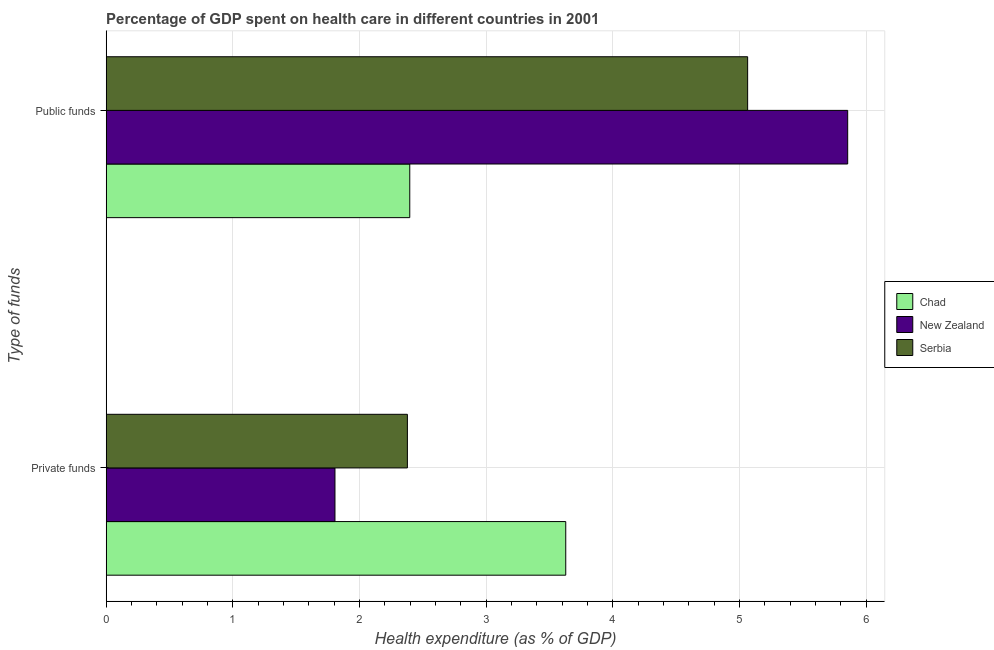How many groups of bars are there?
Provide a short and direct response. 2. Are the number of bars per tick equal to the number of legend labels?
Make the answer very short. Yes. What is the label of the 1st group of bars from the top?
Your answer should be very brief. Public funds. What is the amount of private funds spent in healthcare in New Zealand?
Offer a very short reply. 1.81. Across all countries, what is the maximum amount of public funds spent in healthcare?
Make the answer very short. 5.85. Across all countries, what is the minimum amount of private funds spent in healthcare?
Give a very brief answer. 1.81. In which country was the amount of public funds spent in healthcare maximum?
Offer a very short reply. New Zealand. In which country was the amount of public funds spent in healthcare minimum?
Give a very brief answer. Chad. What is the total amount of public funds spent in healthcare in the graph?
Provide a succinct answer. 13.31. What is the difference between the amount of public funds spent in healthcare in New Zealand and that in Serbia?
Provide a short and direct response. 0.79. What is the difference between the amount of private funds spent in healthcare in New Zealand and the amount of public funds spent in healthcare in Serbia?
Your answer should be very brief. -3.26. What is the average amount of public funds spent in healthcare per country?
Offer a terse response. 4.44. What is the difference between the amount of public funds spent in healthcare and amount of private funds spent in healthcare in Serbia?
Ensure brevity in your answer.  2.69. What is the ratio of the amount of public funds spent in healthcare in New Zealand to that in Chad?
Ensure brevity in your answer.  2.44. What does the 1st bar from the top in Private funds represents?
Provide a short and direct response. Serbia. What does the 3rd bar from the bottom in Public funds represents?
Give a very brief answer. Serbia. How many bars are there?
Your answer should be very brief. 6. Are all the bars in the graph horizontal?
Make the answer very short. Yes. How many countries are there in the graph?
Offer a terse response. 3. What is the difference between two consecutive major ticks on the X-axis?
Give a very brief answer. 1. How many legend labels are there?
Ensure brevity in your answer.  3. How are the legend labels stacked?
Provide a succinct answer. Vertical. What is the title of the graph?
Offer a very short reply. Percentage of GDP spent on health care in different countries in 2001. Does "Middle East & North Africa (all income levels)" appear as one of the legend labels in the graph?
Keep it short and to the point. No. What is the label or title of the X-axis?
Offer a terse response. Health expenditure (as % of GDP). What is the label or title of the Y-axis?
Keep it short and to the point. Type of funds. What is the Health expenditure (as % of GDP) of Chad in Private funds?
Your answer should be very brief. 3.63. What is the Health expenditure (as % of GDP) of New Zealand in Private funds?
Offer a terse response. 1.81. What is the Health expenditure (as % of GDP) of Serbia in Private funds?
Make the answer very short. 2.38. What is the Health expenditure (as % of GDP) in Chad in Public funds?
Your answer should be compact. 2.4. What is the Health expenditure (as % of GDP) of New Zealand in Public funds?
Ensure brevity in your answer.  5.85. What is the Health expenditure (as % of GDP) in Serbia in Public funds?
Keep it short and to the point. 5.06. Across all Type of funds, what is the maximum Health expenditure (as % of GDP) of Chad?
Provide a succinct answer. 3.63. Across all Type of funds, what is the maximum Health expenditure (as % of GDP) of New Zealand?
Provide a short and direct response. 5.85. Across all Type of funds, what is the maximum Health expenditure (as % of GDP) of Serbia?
Provide a succinct answer. 5.06. Across all Type of funds, what is the minimum Health expenditure (as % of GDP) in Chad?
Make the answer very short. 2.4. Across all Type of funds, what is the minimum Health expenditure (as % of GDP) of New Zealand?
Your answer should be very brief. 1.81. Across all Type of funds, what is the minimum Health expenditure (as % of GDP) of Serbia?
Keep it short and to the point. 2.38. What is the total Health expenditure (as % of GDP) in Chad in the graph?
Provide a short and direct response. 6.02. What is the total Health expenditure (as % of GDP) in New Zealand in the graph?
Your answer should be compact. 7.66. What is the total Health expenditure (as % of GDP) of Serbia in the graph?
Provide a short and direct response. 7.44. What is the difference between the Health expenditure (as % of GDP) of Chad in Private funds and that in Public funds?
Ensure brevity in your answer.  1.23. What is the difference between the Health expenditure (as % of GDP) in New Zealand in Private funds and that in Public funds?
Give a very brief answer. -4.05. What is the difference between the Health expenditure (as % of GDP) in Serbia in Private funds and that in Public funds?
Offer a very short reply. -2.69. What is the difference between the Health expenditure (as % of GDP) in Chad in Private funds and the Health expenditure (as % of GDP) in New Zealand in Public funds?
Ensure brevity in your answer.  -2.23. What is the difference between the Health expenditure (as % of GDP) of Chad in Private funds and the Health expenditure (as % of GDP) of Serbia in Public funds?
Provide a short and direct response. -1.44. What is the difference between the Health expenditure (as % of GDP) of New Zealand in Private funds and the Health expenditure (as % of GDP) of Serbia in Public funds?
Ensure brevity in your answer.  -3.26. What is the average Health expenditure (as % of GDP) in Chad per Type of funds?
Provide a succinct answer. 3.01. What is the average Health expenditure (as % of GDP) of New Zealand per Type of funds?
Offer a terse response. 3.83. What is the average Health expenditure (as % of GDP) in Serbia per Type of funds?
Keep it short and to the point. 3.72. What is the difference between the Health expenditure (as % of GDP) of Chad and Health expenditure (as % of GDP) of New Zealand in Private funds?
Your response must be concise. 1.82. What is the difference between the Health expenditure (as % of GDP) of Chad and Health expenditure (as % of GDP) of Serbia in Private funds?
Offer a very short reply. 1.25. What is the difference between the Health expenditure (as % of GDP) of New Zealand and Health expenditure (as % of GDP) of Serbia in Private funds?
Offer a very short reply. -0.57. What is the difference between the Health expenditure (as % of GDP) in Chad and Health expenditure (as % of GDP) in New Zealand in Public funds?
Give a very brief answer. -3.46. What is the difference between the Health expenditure (as % of GDP) of Chad and Health expenditure (as % of GDP) of Serbia in Public funds?
Provide a short and direct response. -2.67. What is the difference between the Health expenditure (as % of GDP) of New Zealand and Health expenditure (as % of GDP) of Serbia in Public funds?
Keep it short and to the point. 0.79. What is the ratio of the Health expenditure (as % of GDP) of Chad in Private funds to that in Public funds?
Offer a terse response. 1.51. What is the ratio of the Health expenditure (as % of GDP) of New Zealand in Private funds to that in Public funds?
Provide a short and direct response. 0.31. What is the ratio of the Health expenditure (as % of GDP) in Serbia in Private funds to that in Public funds?
Offer a very short reply. 0.47. What is the difference between the highest and the second highest Health expenditure (as % of GDP) of Chad?
Offer a very short reply. 1.23. What is the difference between the highest and the second highest Health expenditure (as % of GDP) in New Zealand?
Your response must be concise. 4.05. What is the difference between the highest and the second highest Health expenditure (as % of GDP) of Serbia?
Make the answer very short. 2.69. What is the difference between the highest and the lowest Health expenditure (as % of GDP) in Chad?
Provide a short and direct response. 1.23. What is the difference between the highest and the lowest Health expenditure (as % of GDP) of New Zealand?
Your answer should be very brief. 4.05. What is the difference between the highest and the lowest Health expenditure (as % of GDP) in Serbia?
Provide a succinct answer. 2.69. 